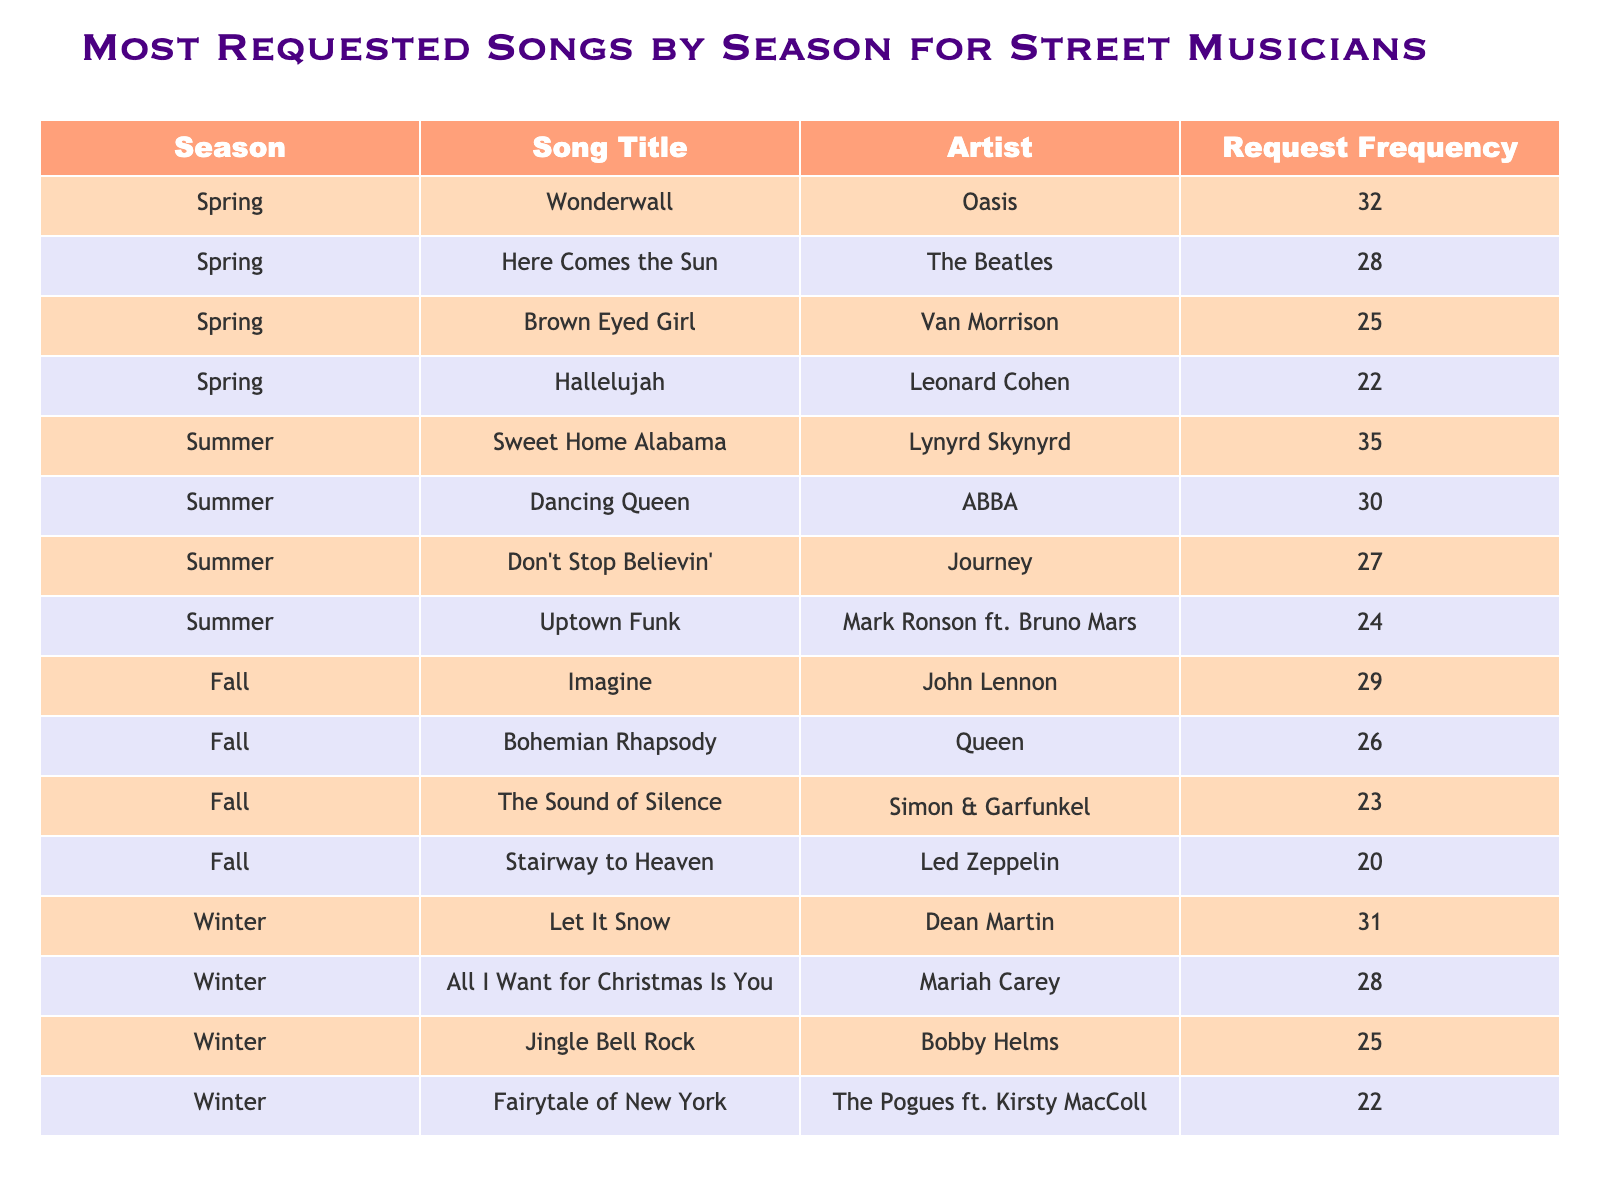What is the most requested song in Spring? Referring to the Spring row in the table, the song with the highest request frequency is "Wonderwall" by Oasis, which has a request frequency of 32.
Answer: Wonderwall Which song was requested more in Winter: "Let It Snow" or "All I Want for Christmas Is You"? Comparing the request frequencies from the Winter section, "Let It Snow" has a frequency of 31, while "All I Want for Christmas Is You" has 28. Therefore, "Let It Snow" was requested more.
Answer: Let It Snow What is the total number of requests for songs in Summer? To find the total requests in Summer, add the request frequencies: 35 + 30 + 27 + 24 = 116.
Answer: 116 Is "Stairway to Heaven" the most requested song in the Fall? In the Fall section, "Stairway to Heaven" has a frequency of 20, while "Imagine" has 29 and "Bohemian Rhapsody" has 26. Since 20 is less than both, it is not the most requested.
Answer: No Which season has the highest average request frequency for songs? First, calculate the average for each season: Spring = (32 + 28 + 25 + 22) / 4 = 26.75, Summer = (35 + 30 + 27 + 24) / 4 = 29, Fall = (29 + 26 + 23 + 20) / 4 = 24.5, and Winter = (31 + 28 + 25 + 22) / 4 = 26.5. The highest average is for Summer, at 29.
Answer: Summer What is the request frequency difference between the most popular song in Winter and the most popular song in Spring? The most popular song in Winter is "Let It Snow" with 31 requests, and in Spring, it is "Wonderwall" with 32 requests. The difference is 32 - 31 = 1.
Answer: 1 Which song received more requests: "Dancing Queen" or "Here Comes the Sun"? "Dancing Queen" has 30 requests, while "Here Comes the Sun" has 28 requests. Therefore, "Dancing Queen" received more requests.
Answer: Dancing Queen What is the least requested song in the table? Among the songs listed, "Fairytale of New York" in Winter has the lowest request frequency at 22.
Answer: Fairytale of New York How many songs have a request frequency of 25 or more in Fall? The request frequencies for Fall are: 29, 26, 23, and 20. The songs with 25 or more are "Imagine" (29), "Bohemian Rhapsody" (26), and "The Sound of Silence" (23). Thus, there are 3 songs with 25 or more requests.
Answer: 3 What is the range of request frequencies in Spring? The highest request frequency in Spring is 32 (Wonderwall), and the lowest is 22 (Hallelujah). Therefore, the range is 32 - 22 = 10.
Answer: 10 